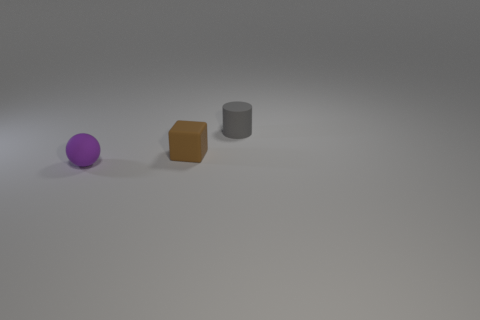Does the rubber cylinder have the same color as the cube?
Make the answer very short. No. What number of purple rubber spheres have the same size as the matte cylinder?
Make the answer very short. 1. There is a object behind the brown matte block; does it have the same size as the rubber object to the left of the tiny brown matte object?
Provide a short and direct response. Yes. What shape is the small rubber object that is to the right of the purple sphere and in front of the gray cylinder?
Provide a short and direct response. Cube. Are there any tiny matte spheres that have the same color as the tiny matte block?
Provide a succinct answer. No. Are any red objects visible?
Your response must be concise. No. What is the color of the rubber object that is behind the tiny matte cube?
Your response must be concise. Gray. Is the size of the rubber cylinder the same as the rubber object in front of the tiny brown block?
Your answer should be compact. Yes. What size is the matte object that is both in front of the gray matte cylinder and behind the purple rubber object?
Keep it short and to the point. Small. Are there any tiny things made of the same material as the brown block?
Keep it short and to the point. Yes. 